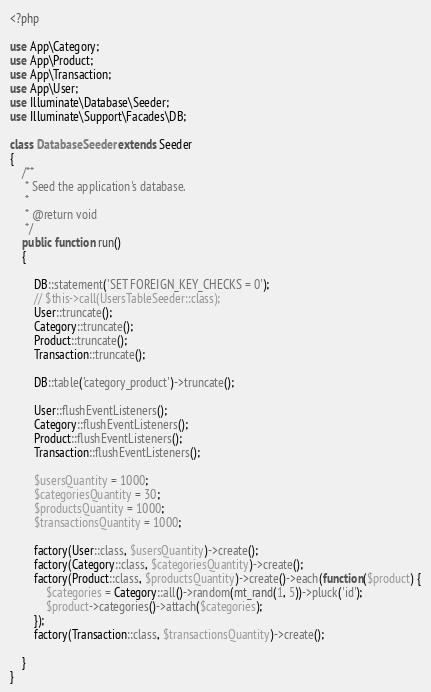<code> <loc_0><loc_0><loc_500><loc_500><_PHP_><?php

use App\Category;
use App\Product;
use App\Transaction;
use App\User;
use Illuminate\Database\Seeder;
use Illuminate\Support\Facades\DB;

class DatabaseSeeder extends Seeder
{
    /**
     * Seed the application's database.
     *
     * @return void
     */
    public function run()
    {
    	
    	DB::statement('SET FOREIGN_KEY_CHECKS = 0');
        // $this->call(UsersTableSeeder::class);
        User::truncate();
        Category::truncate();
        Product::truncate();
        Transaction::truncate();

        DB::table('category_product')->truncate();

        User::flushEventListeners();
        Category::flushEventListeners();
        Product::flushEventListeners();
        Transaction::flushEventListeners();

        $usersQuantity = 1000;
        $categoriesQuantity = 30;
        $productsQuantity = 1000;
        $transactionsQuantity = 1000;

        factory(User::class, $usersQuantity)->create();
        factory(Category::class, $categoriesQuantity)->create();
        factory(Product::class, $productsQuantity)->create()->each(function($product) {
        	$categories = Category::all()->random(mt_rand(1, 5))->pluck('id');
        	$product->categories()->attach($categories);
        });
        factory(Transaction::class, $transactionsQuantity)->create();

    }
}
</code> 